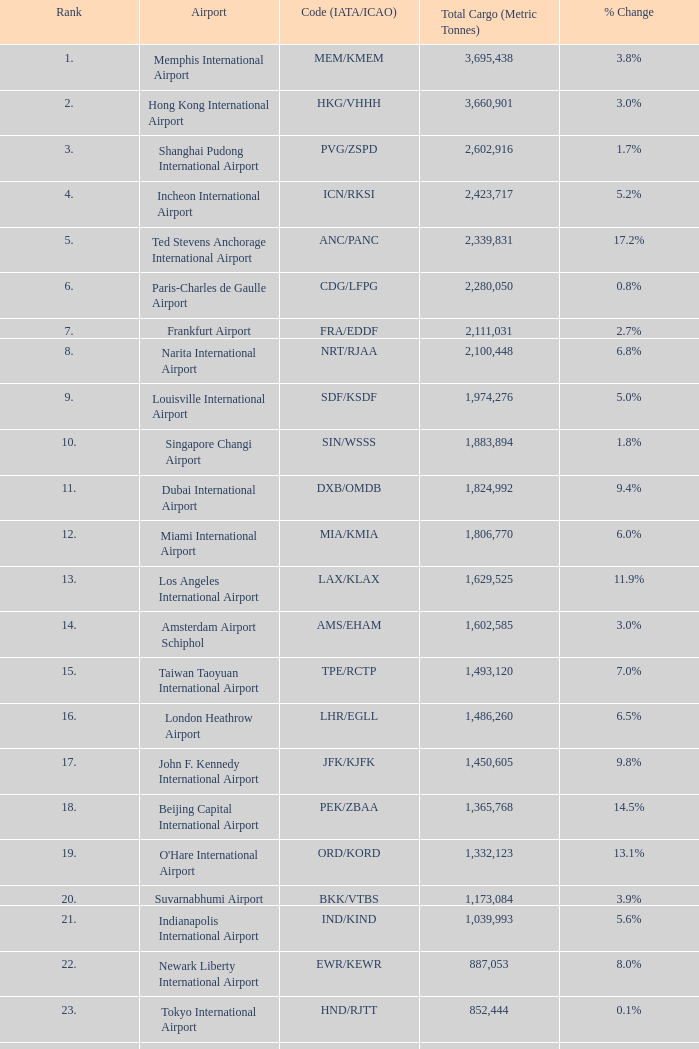Can you provide the code associated with rank 10? SIN/WSSS. 